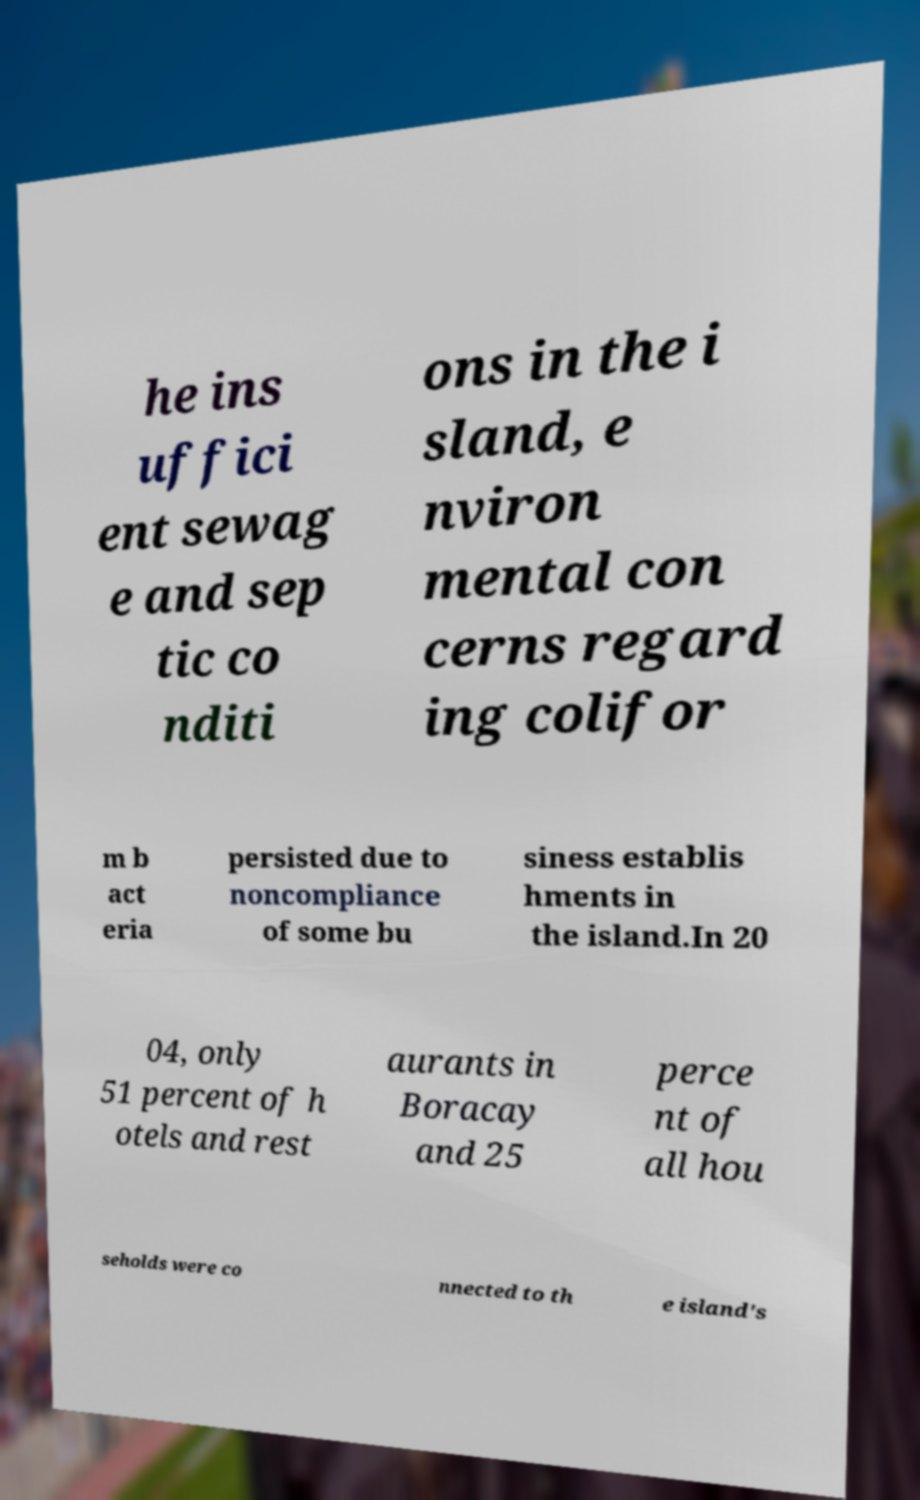I need the written content from this picture converted into text. Can you do that? he ins uffici ent sewag e and sep tic co nditi ons in the i sland, e nviron mental con cerns regard ing colifor m b act eria persisted due to noncompliance of some bu siness establis hments in the island.In 20 04, only 51 percent of h otels and rest aurants in Boracay and 25 perce nt of all hou seholds were co nnected to th e island's 